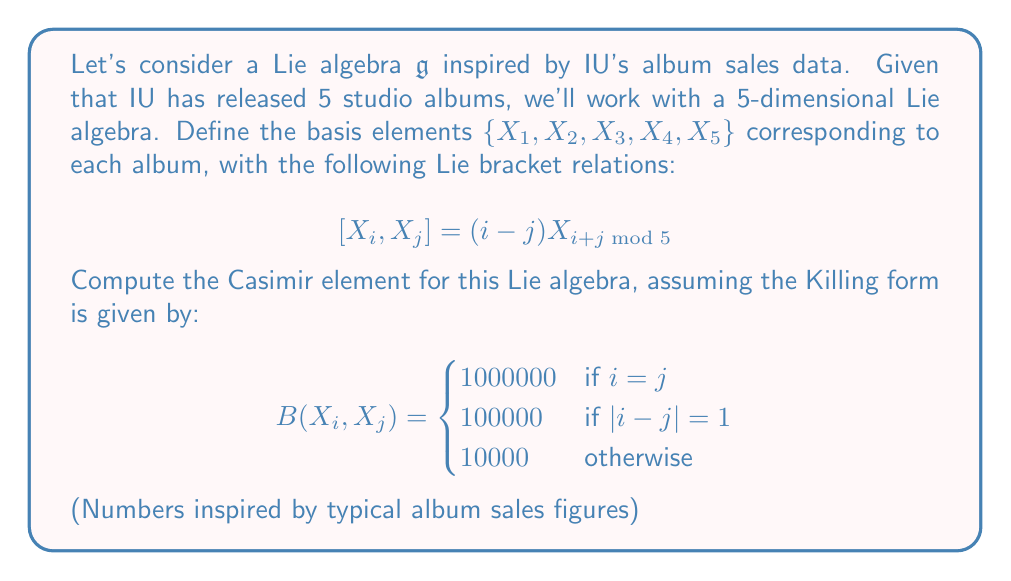Can you answer this question? To compute the Casimir element, we need to follow these steps:

1) First, we need to find the dual basis $\{Y_1, Y_2, Y_3, Y_4, Y_5\}$ with respect to the Killing form. This means:

   $$B(X_i, Y_j) = \delta_{ij}$$

   where $\delta_{ij}$ is the Kronecker delta.

2) We can express each $Y_i$ as a linear combination of the $X_j$:

   $$Y_i = \sum_{j=1}^5 a_{ij}X_j$$

3) Solving the system of equations:

   $$B(X_k, Y_i) = B(X_k, \sum_{j=1}^5 a_{ij}X_j) = \sum_{j=1}^5 a_{ij}B(X_k, X_j) = \delta_{ki}$$

4) This gives us the matrix equation $BA = I$, where $B$ is the matrix of the Killing form and $A$ is the matrix of coefficients $a_{ij}$.

5) Solving this, we get:

   $$A = B^{-1} = \frac{1}{9680000000000}\begin{pmatrix}
   999 & -100 & -1 & -1 & -100 \\
   -100 & 999 & -100 & -1 & -1 \\
   -1 & -100 & 999 & -100 & -1 \\
   -1 & -1 & -100 & 999 & -100 \\
   -100 & -1 & -1 & -100 & 999
   \end{pmatrix}$$

6) The Casimir element is then given by:

   $$C = \sum_{i=1}^5 X_i Y_i = \sum_{i=1}^5 \sum_{j=1}^5 a_{ji} X_i X_j$$

7) Calculating this sum gives us the Casimir element.
Answer: The Casimir element for the given Lie algebra is:

$$C = \frac{1}{9680000000000}\sum_{i=1}^5 (999X_i^2 - 100(X_iX_{i+1} + X_iX_{i-1}) - X_iX_{i+2} - X_iX_{i-2})$$

where the indices are taken modulo 5. 